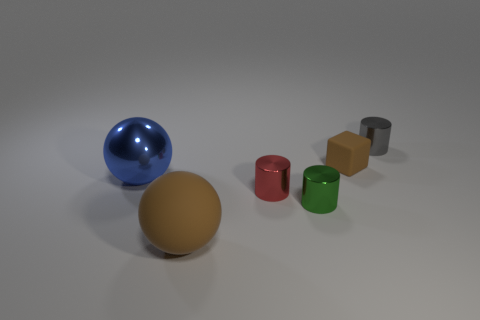Is the number of small brown matte things that are in front of the tiny brown block less than the number of small blue matte cubes?
Make the answer very short. No. Do the gray object and the small green thing have the same shape?
Keep it short and to the point. Yes. What is the size of the red object that is on the right side of the blue metallic object?
Your answer should be compact. Small. What is the size of the blue object that is the same material as the small green cylinder?
Provide a short and direct response. Large. Are there fewer green cylinders than small metal things?
Ensure brevity in your answer.  Yes. There is a cube that is the same size as the red cylinder; what material is it?
Provide a short and direct response. Rubber. Are there more tiny brown matte things than tiny cylinders?
Make the answer very short. No. How many other things are the same color as the big matte thing?
Your answer should be very brief. 1. How many brown matte objects are both in front of the green shiny object and to the right of the red metal object?
Offer a terse response. 0. Is the number of small things behind the small brown rubber object greater than the number of blue shiny objects that are in front of the large blue object?
Your response must be concise. Yes. 